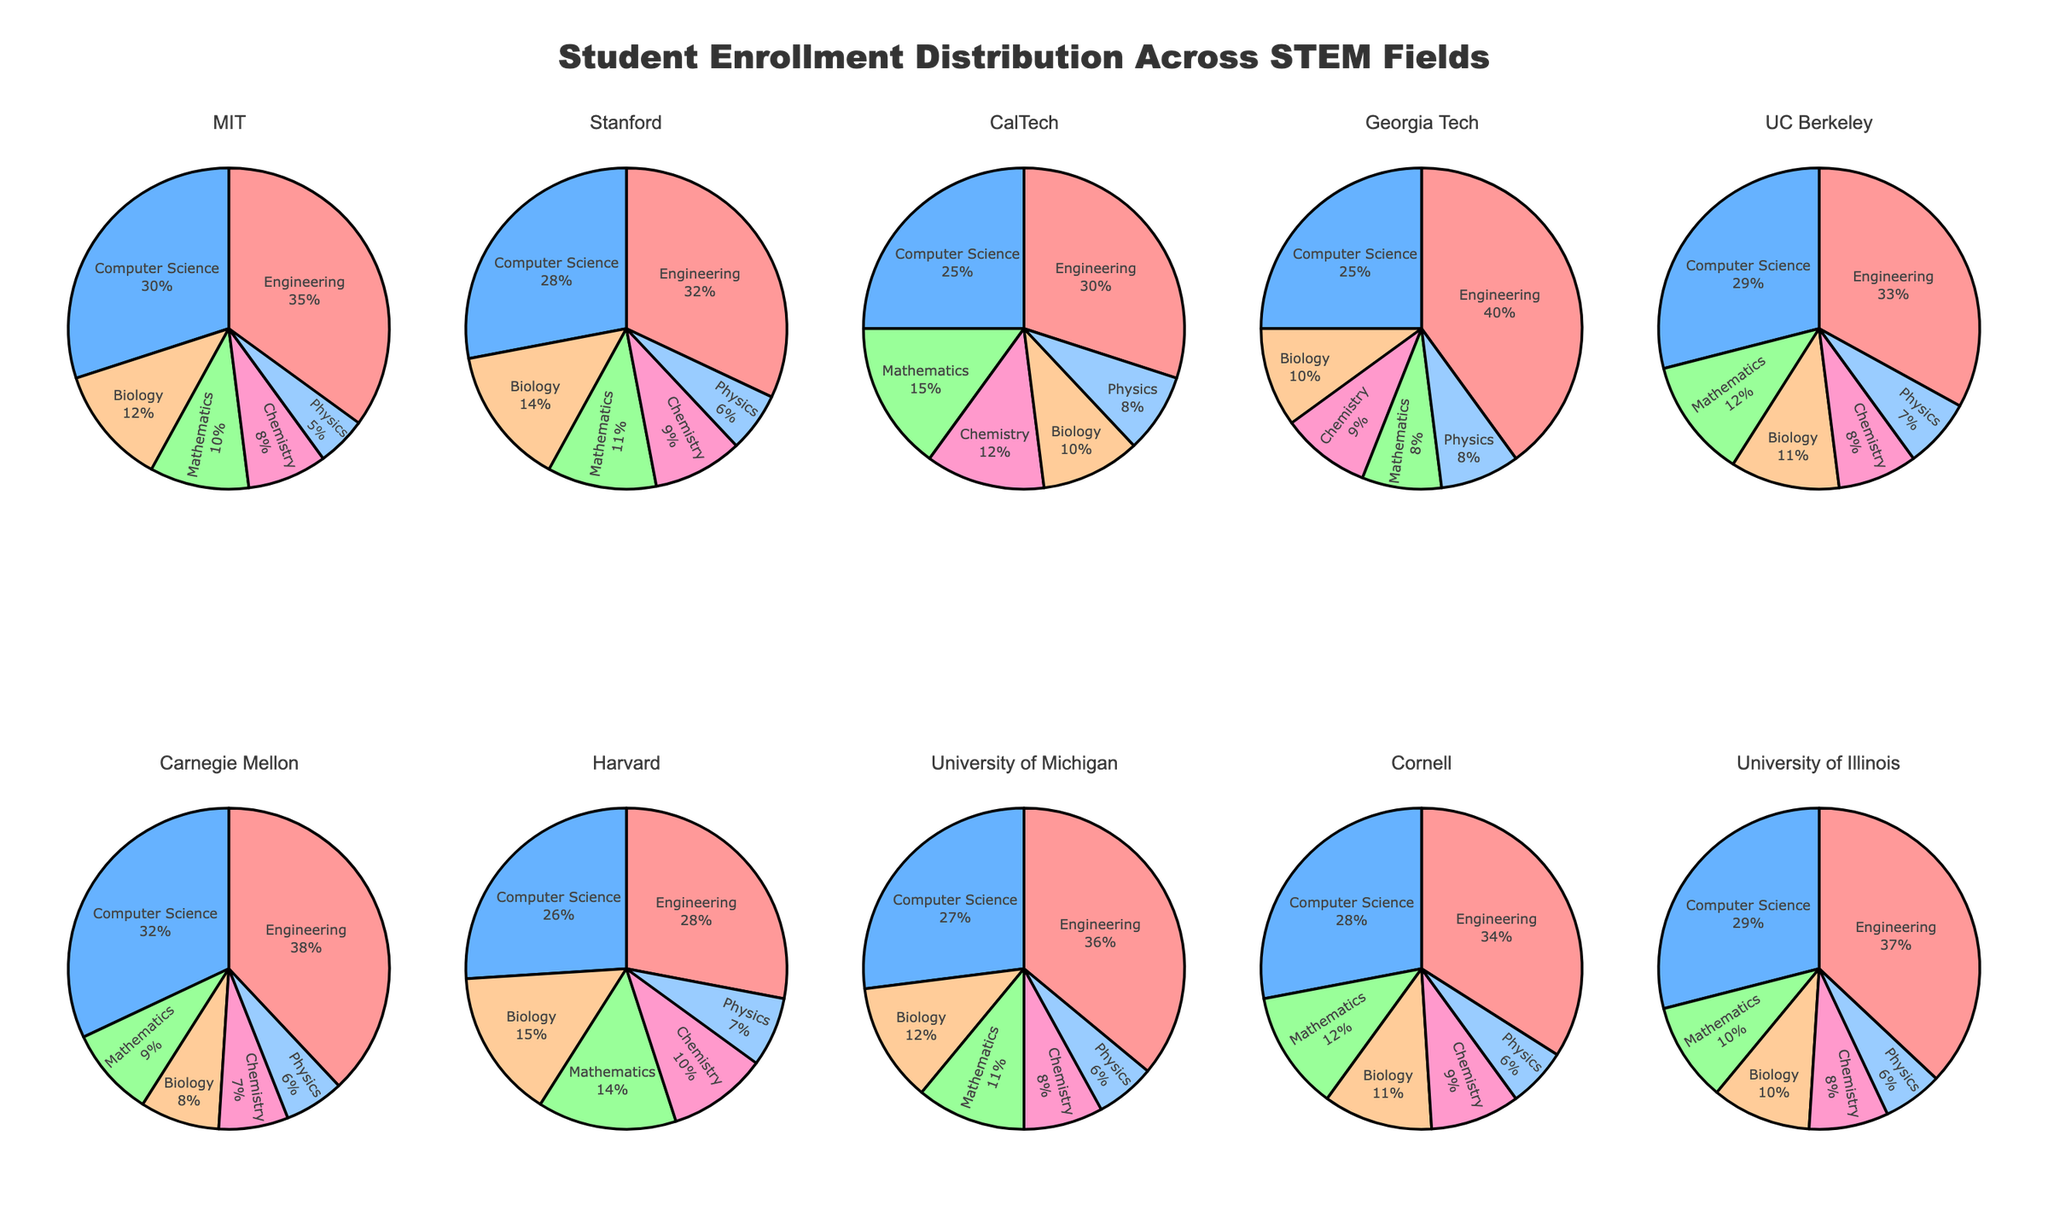What is the title of the figure? The title of the figure is located at the top and reads "Student Enrollment Distribution Across STEM Fields".
Answer: Student Enrollment Distribution Across STEM Fields Which university has the highest proportion of students enrolled in Engineering? By looking at the proportions of each pie chart, Georgia Tech has the highest proportion of students enrolled in Engineering, as their Engineering section appears the largest.
Answer: Georgia Tech What are the fields represented in the pie charts? Each pie chart is divided into sections corresponding to different STEM fields. By examining the legend or labels, the fields are Engineering, Computer Science, Mathematics, Biology, Chemistry, and Physics.
Answer: Engineering, Computer Science, Mathematics, Biology, Chemistry, Physics Compare the percentage of Computer Science students between MIT and Stanford. By looking at the respective segments in MIT and Stanford's pie charts, both have a similar but not identical proportion of students in Computer Science, with MIT slightly higher.
Answer: MIT In which university is Mathematics enrollment the highest? Each segment representing Mathematics can be compared among all universities. CalTech’s chunk of the pie chart shows the largest proportion, indicating the highest enrollment.
Answer: CalTech Rank the universities based on the number of STEM fields with the lowest percentage enrollments in Physics. By examining the smallest segment in each pie chart, the universities can be compared: Carnegie Mellon has the smallest proportion of students in Physics.
Answer: Carnegie Mellon, MIT, Stanford, University of Illinois, Cornell, Harvard, UC Berkeley, University of Michigan, Georgia Tech, CalTech Which university has an even distribution of student enrollment across the six fields? By comparing the pie charts, universities with relatively equal-sized segments are sought. CalTech and Harvard show more evenly divided sections amongst the fields.
Answer: CalTech, Harvard What is the total percentage of students enrolled in Biology and Chemistry combined at Harvard? By adding the percentages of Biology and Chemistry sections in Harvard's pie chart, it amounts to approximately 25% + 17% = 42%.
Answer: 42% Which two universities have the closest percentage of enrollments in Physics? By comparing the size of the Physics sections across all charts, you can observe that Stanford and University of Michigan have similar proportions.
Answer: Stanford, University of Michigan 